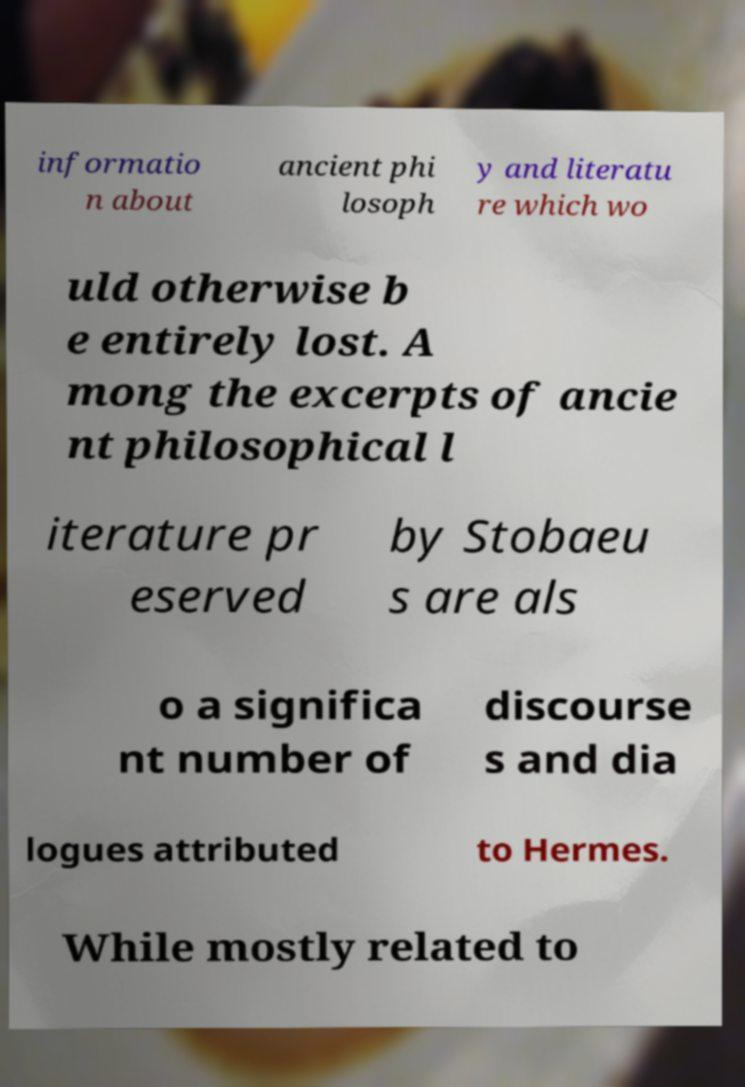Please read and relay the text visible in this image. What does it say? informatio n about ancient phi losoph y and literatu re which wo uld otherwise b e entirely lost. A mong the excerpts of ancie nt philosophical l iterature pr eserved by Stobaeu s are als o a significa nt number of discourse s and dia logues attributed to Hermes. While mostly related to 